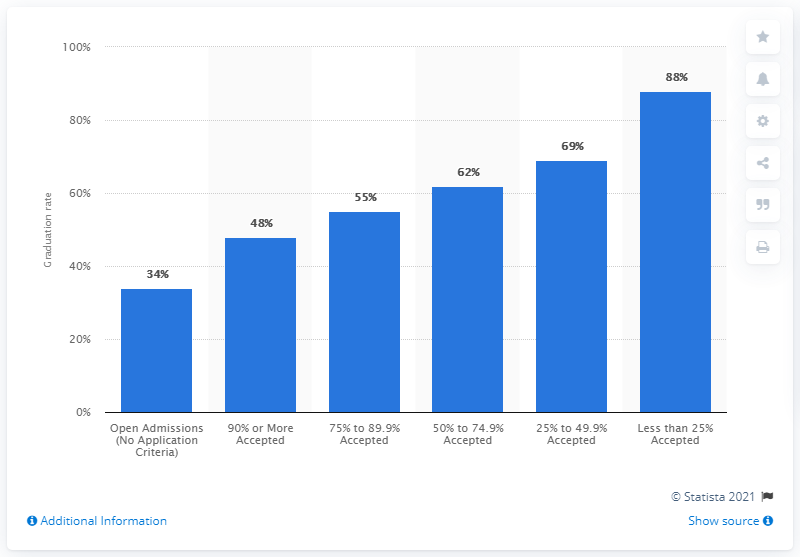List a handful of essential elements in this visual. The graduation rate of all students who were enrolled in colleges that had open admission in 2007 was 34%. 